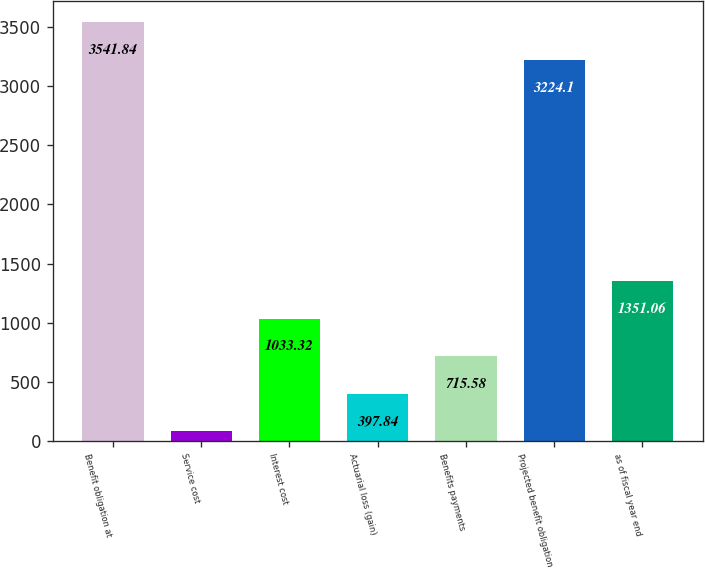<chart> <loc_0><loc_0><loc_500><loc_500><bar_chart><fcel>Benefit obligation at<fcel>Service cost<fcel>Interest cost<fcel>Actuarial loss (gain)<fcel>Benefits payments<fcel>Projected benefit obligation<fcel>as of fiscal year end<nl><fcel>3541.84<fcel>80.1<fcel>1033.32<fcel>397.84<fcel>715.58<fcel>3224.1<fcel>1351.06<nl></chart> 